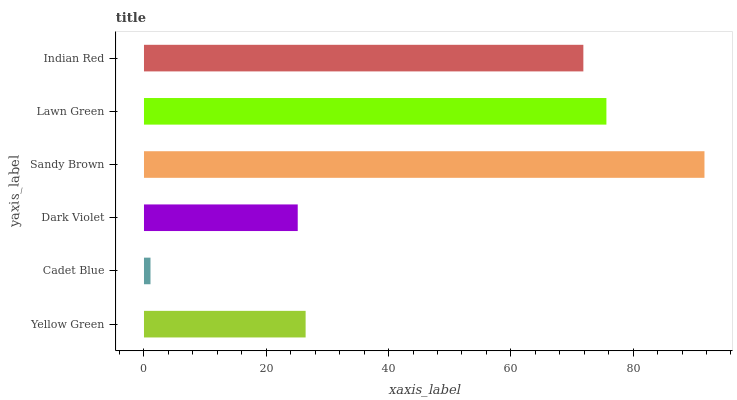Is Cadet Blue the minimum?
Answer yes or no. Yes. Is Sandy Brown the maximum?
Answer yes or no. Yes. Is Dark Violet the minimum?
Answer yes or no. No. Is Dark Violet the maximum?
Answer yes or no. No. Is Dark Violet greater than Cadet Blue?
Answer yes or no. Yes. Is Cadet Blue less than Dark Violet?
Answer yes or no. Yes. Is Cadet Blue greater than Dark Violet?
Answer yes or no. No. Is Dark Violet less than Cadet Blue?
Answer yes or no. No. Is Indian Red the high median?
Answer yes or no. Yes. Is Yellow Green the low median?
Answer yes or no. Yes. Is Lawn Green the high median?
Answer yes or no. No. Is Cadet Blue the low median?
Answer yes or no. No. 